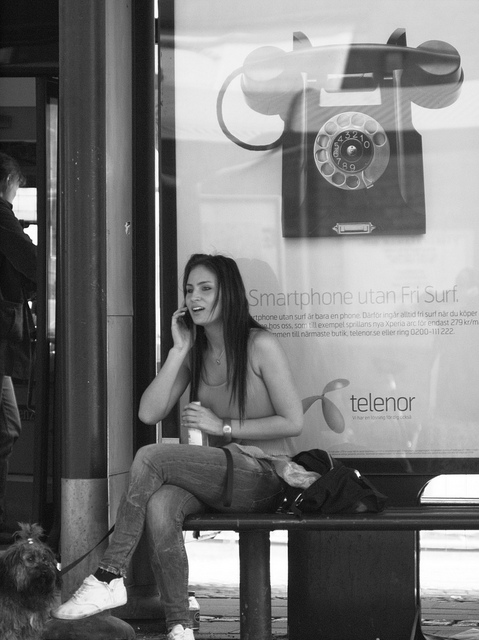Please identify all text content in this image. Smartphone utan Fri Surf telenor 279 10200-111-222 9 6 4 2 o 1 